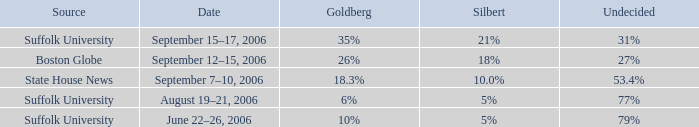What is the date of the poll with Silbert at 18%? September 12–15, 2006. 